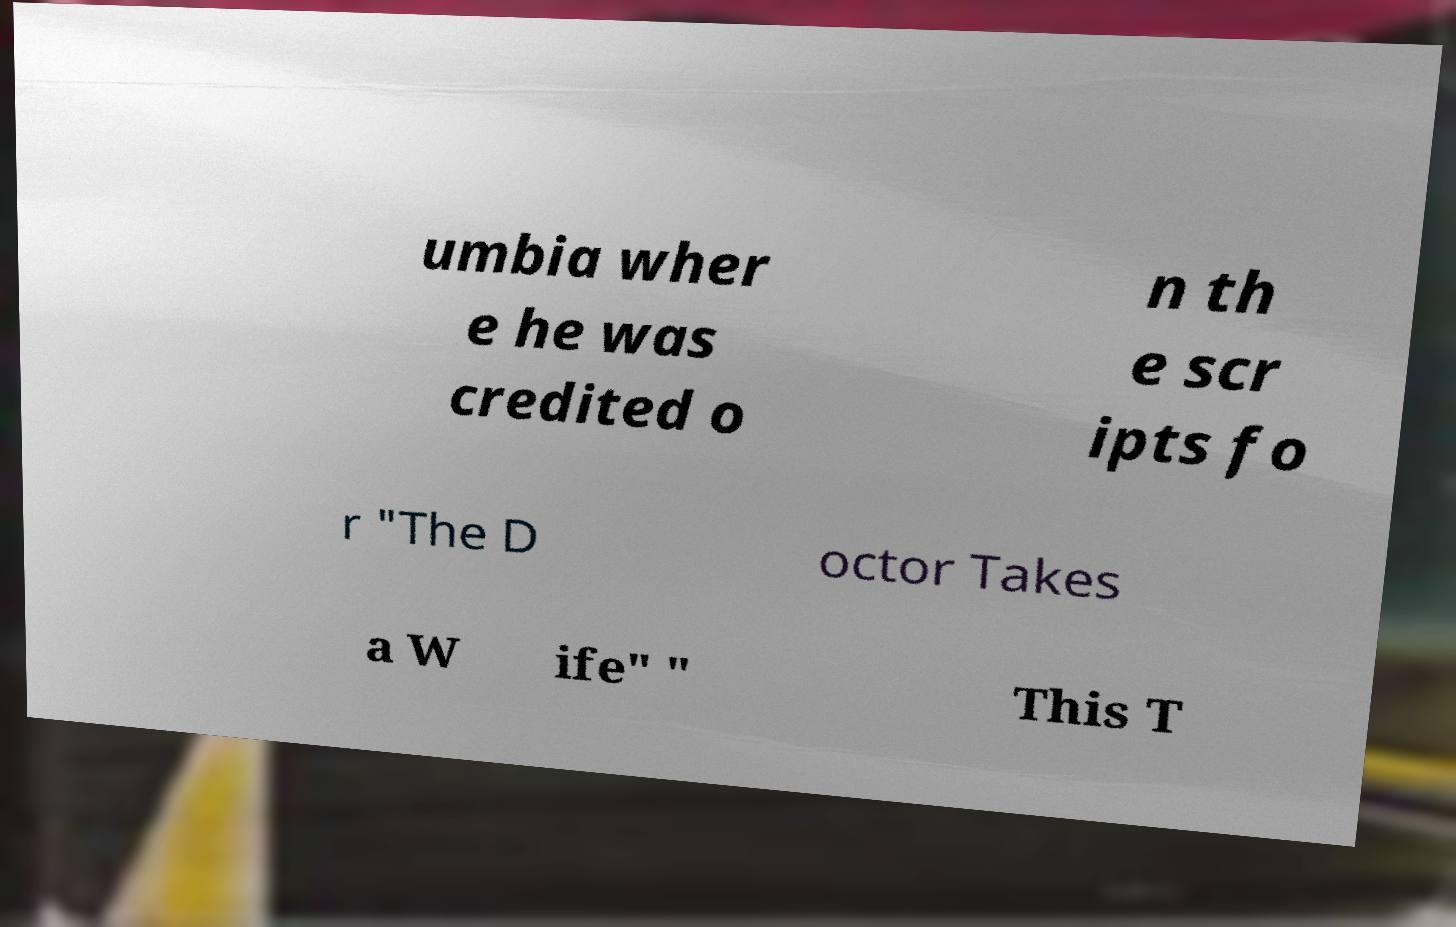Can you accurately transcribe the text from the provided image for me? umbia wher e he was credited o n th e scr ipts fo r "The D octor Takes a W ife" " This T 